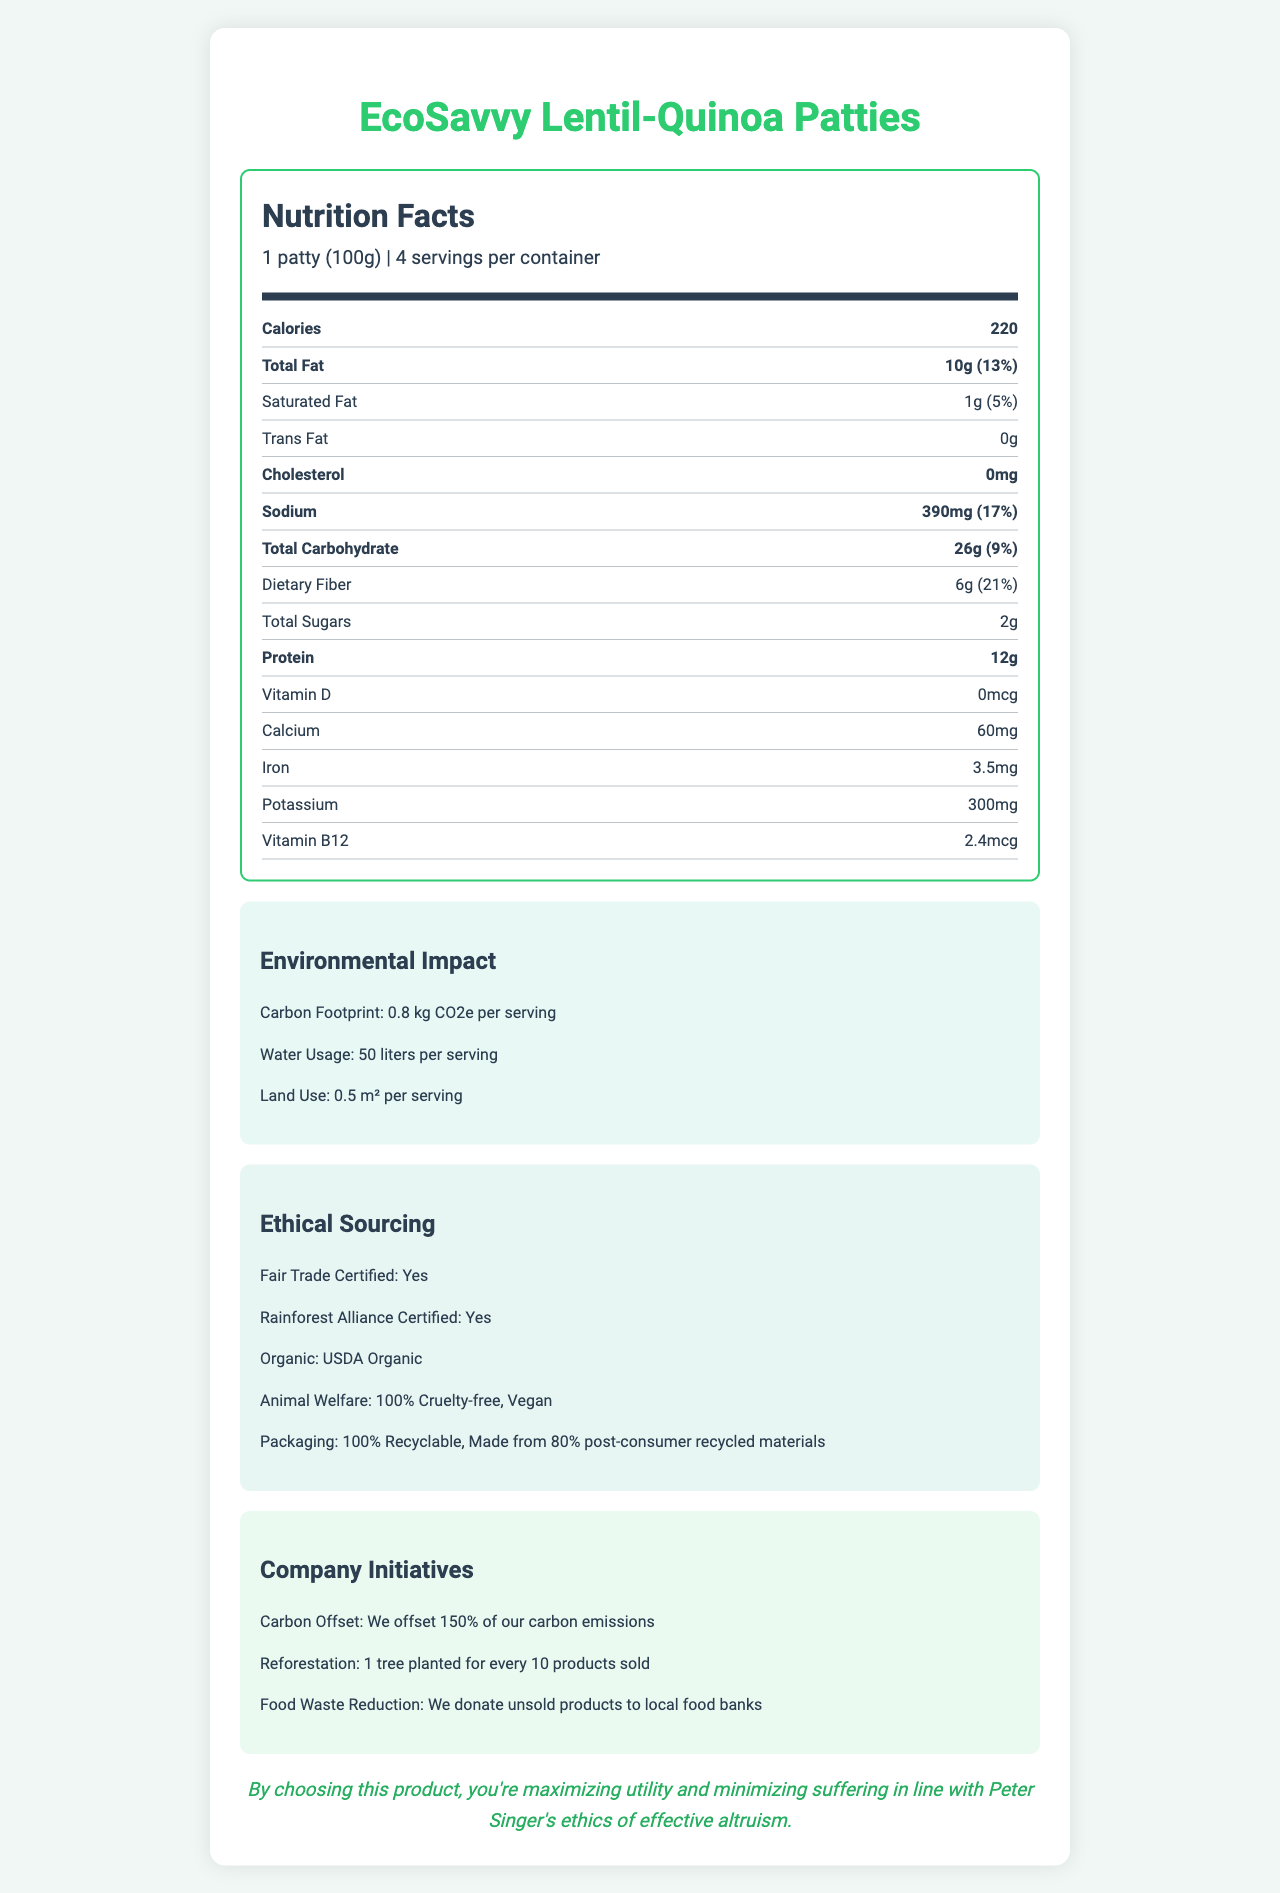what is the serving size? The serving size is specified at the top of the nutrition facts section, mentioning 1 patty (100g).
Answer: 1 patty (100g) how many calories are in one serving? The document states the calorie content is 220 per serving.
Answer: 220 what is the total fat content per serving? The nutrition label indicates that the total fat content per serving is 10g.
Answer: 10g how much protein does one patty contain? The protein content per serving is listed as 12g in the nutrition facts.
Answer: 12g is this product cruelty-free and vegan? The document mentions that the product is 100% cruelty-free and vegan.
Answer: Yes how has the company addressed its carbon emissions? In the company initiatives section, it states that they offset 150% of their carbon emissions.
Answer: We offset 150% of our carbon emissions how much iron is in one serving? The nutrition label shows that one serving contains 3.5mg of iron.
Answer: 3.5mg what are the main ingredients in the product? List three. The ingredients list includes Lentils, Quinoa, and Pea protein among others.
Answer: Lentils, Quinoa, Pea protein what is the daily value percentage of dietary fiber? The document states that the daily value percentage of dietary fiber per serving is 21%.
Answer: 21% which certification labels are associated with this product? A. Fair Trade Certified B. Rainforest Alliance Certified C. USDA Organic D. All of the above The document indicates that the product is Fair Trade Certified, Rainforest Alliance Certified, and USDA Organic.
Answer: D how much water is used per serving? The environmental impact section states that 50 liters of water are used per serving.
Answer: 50 liters how much trans fat does one patty contain? The nutrition label lists trans fat content as 0g.
Answer: 0g which option correctly lists three company initiatives related to the product? i. Offsetting 150% of carbon emissions, Reducing food waste, Recycling packaging ii. Offsetting 150% of carbon emissions, Planting 1 tree for every 10 products sold, Donating unsold products to food banks iii. Planting 1 tree for every 10 products sold, Donating products, Fair Trade Certified The correct options as per the document are offsetting 150% of carbon emissions, planting 1 tree for every 10 products sold, and donating unsold products to local food banks.
Answer: ii is the packaging of this product recyclable? The document mentions that the packaging is 100% recyclable.
Answer: Yes summarize the main ethical and environmental highlights of the product. The summary covers the various ethical sourcing practices, the environmental impact of the product, company initiatives, and the philosophical statement which resonates with Peter Singer's philosophy.
Answer: The EcoSavvy Lentil-Quinoa Patties are a plant-based meat alternative with various ethical and environmental benefits. These include a low carbon footprint and water usage per serving, fair trade and rainforest alliance certifications, and being cruelty-free and vegan. The packaging is recyclable and made from post-consumer recycled materials, and the company offsets its carbon emissions, practices reforestation, and donates unsold products to food banks. The product's choice aligns with maximizing utility and minimizing suffering per Peter Singer's ethics of effective altruism. how is the product coloring achieved? The ingredients list includes beet juice concentrate for color.
Answer: Beet juice concentrate what are the benefits of dietary fiber in the product? The document mentions the dietary fiber content and daily value percentage but does not specify the benefits of dietary fiber in the product.
Answer: Not enough information 